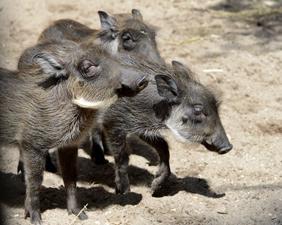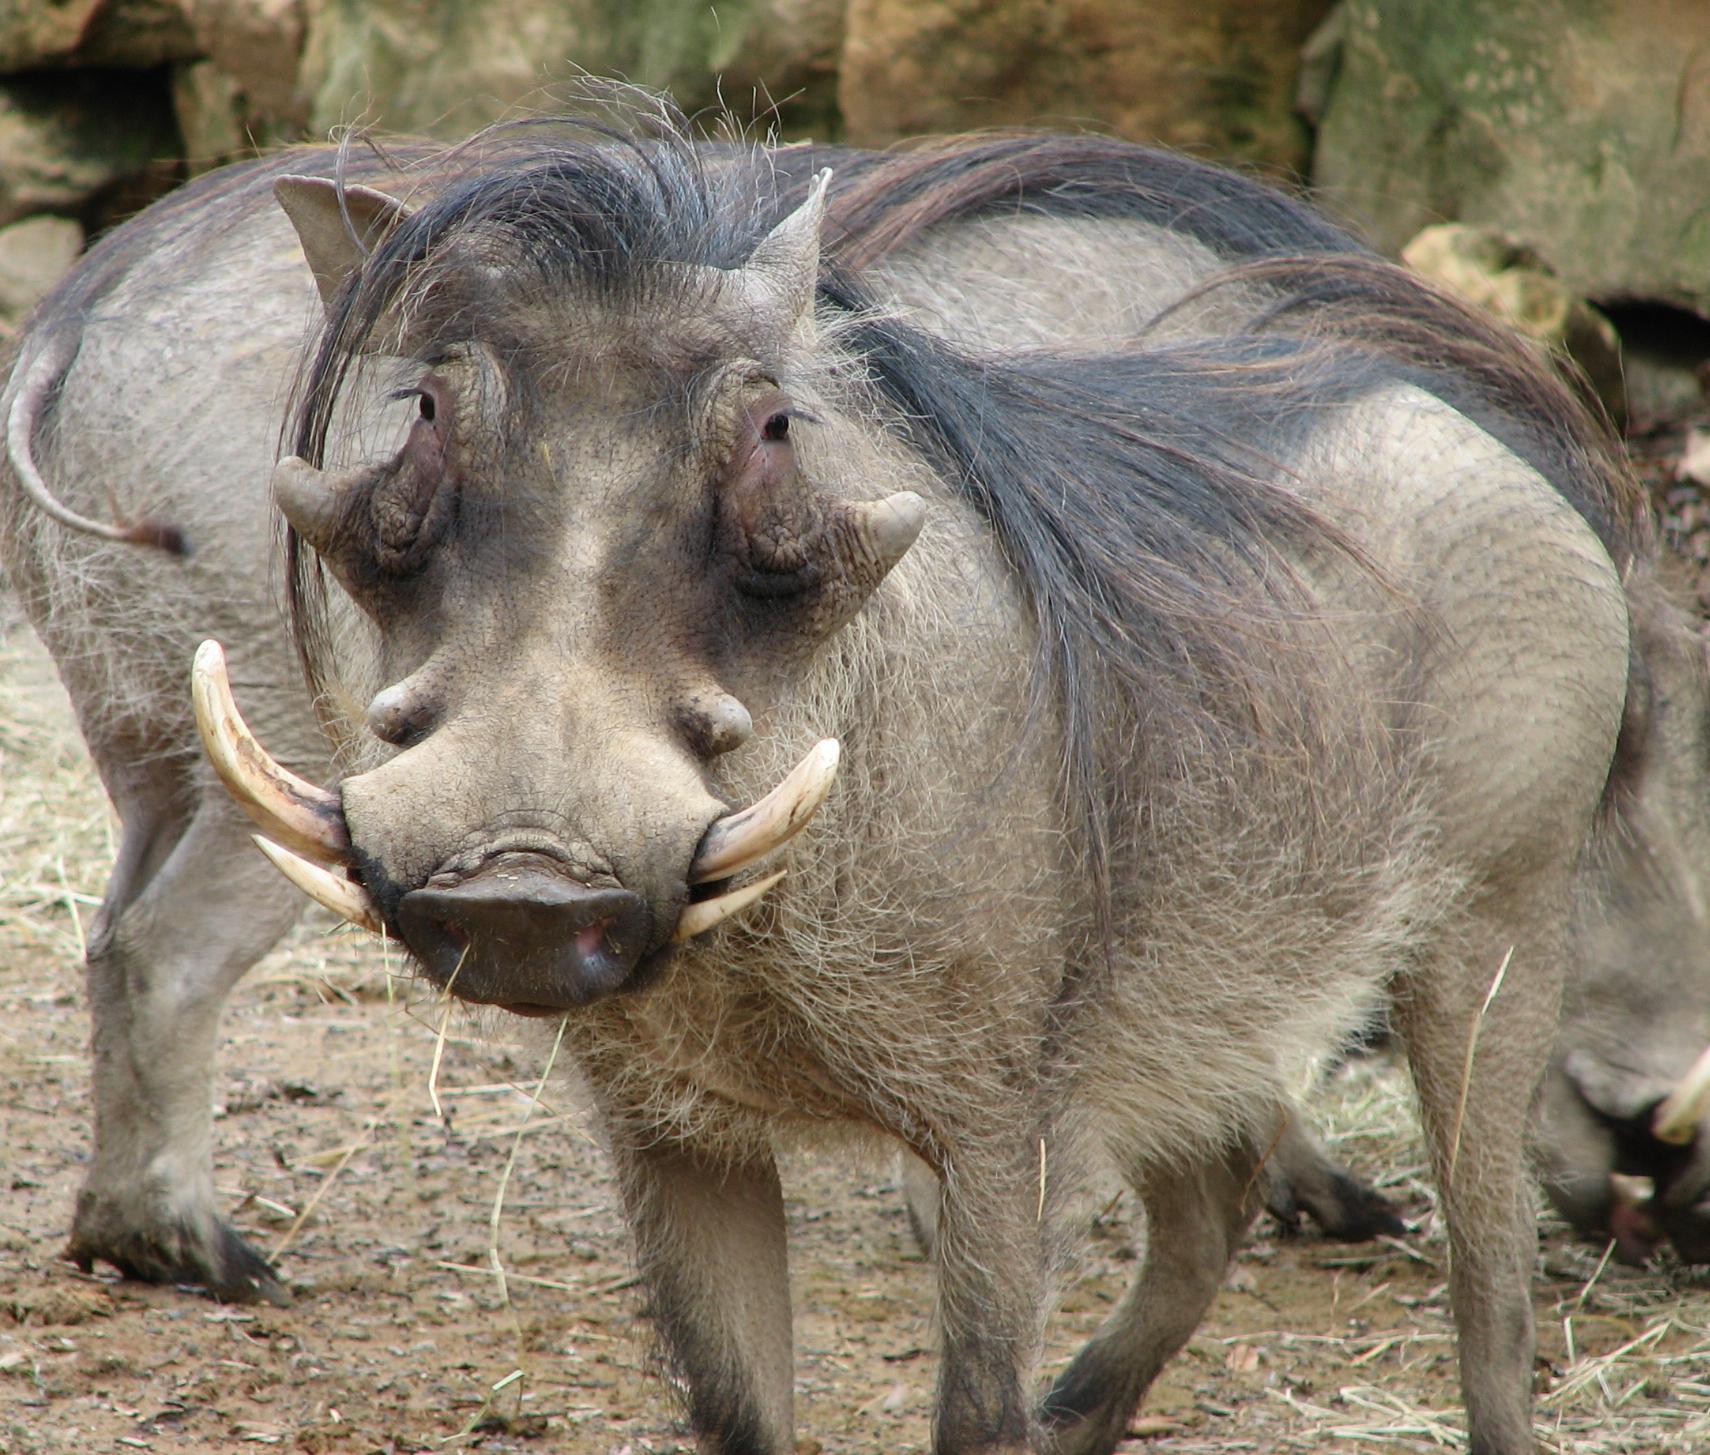The first image is the image on the left, the second image is the image on the right. Examine the images to the left and right. Is the description "There are no more than 3 hogs in total." accurate? Answer yes or no. No. The first image is the image on the left, the second image is the image on the right. For the images displayed, is the sentence "An image contains only young hogs, all without distinctive patterned fur." factually correct? Answer yes or no. Yes. 